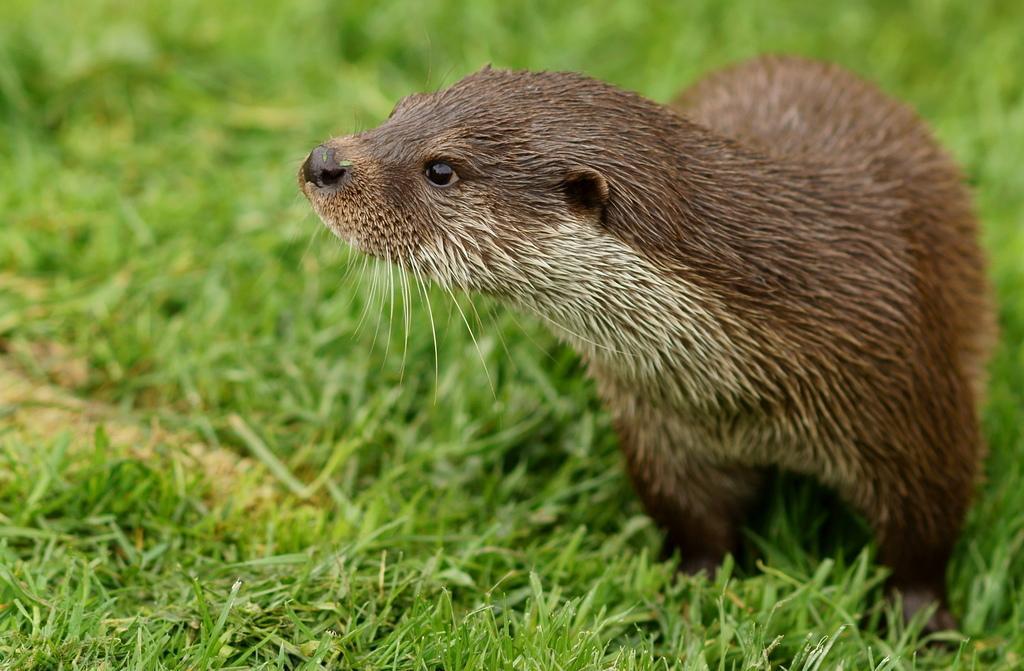Describe this image in one or two sentences. In this picture we can see an animal and this is grass. 